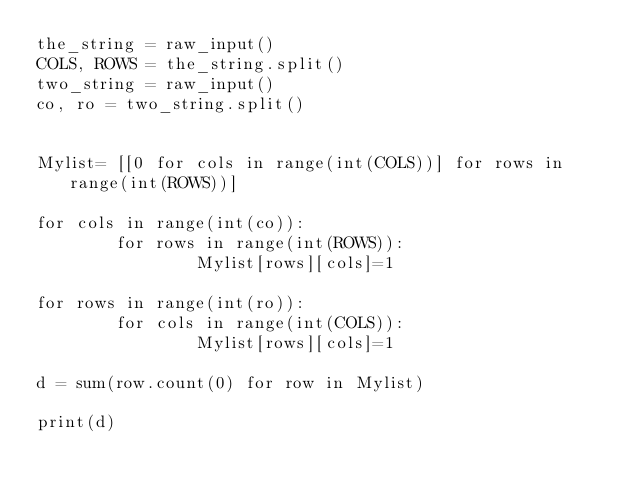<code> <loc_0><loc_0><loc_500><loc_500><_Python_>the_string = raw_input()
COLS, ROWS = the_string.split()
two_string = raw_input()
co, ro = two_string.split()


Mylist= [[0 for cols in range(int(COLS))] for rows in range(int(ROWS))]

for cols in range(int(co)):
        for rows in range(int(ROWS)):
                Mylist[rows][cols]=1

for rows in range(int(ro)):
        for cols in range(int(COLS)):
                Mylist[rows][cols]=1

d = sum(row.count(0) for row in Mylist)

print(d)</code> 